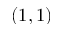Convert formula to latex. <formula><loc_0><loc_0><loc_500><loc_500>( 1 , 1 )</formula> 